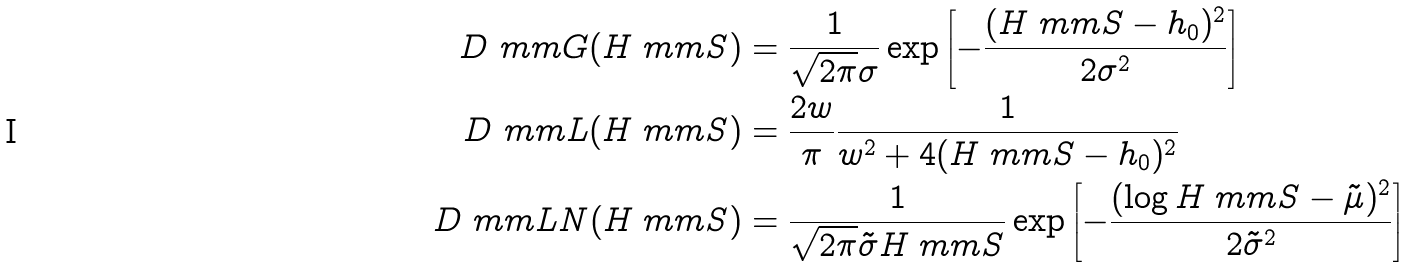Convert formula to latex. <formula><loc_0><loc_0><loc_500><loc_500>D _ { \ } m m { G } ( H _ { \ } m m { S } ) & = \frac { 1 } { \sqrt { 2 \pi } \sigma } \exp \left [ - \frac { ( H _ { \ } m m { S } - h _ { 0 } ) ^ { 2 } } { 2 \sigma ^ { 2 } } \right ] \\ D _ { \ } m m { L } ( H _ { \ } m m { S } ) & = \frac { 2 w } { \pi } \frac { 1 } { w ^ { 2 } + 4 ( H _ { \ } m m { S } - h _ { 0 } ) ^ { 2 } } \\ D _ { \ } m m { L N } ( H _ { \ } m m { S } ) & = \frac { 1 } { \sqrt { 2 \pi } \tilde { \sigma } H _ { \ } m m { S } } \exp \left [ - \frac { ( \log H _ { \ } m m { S } - \tilde { \mu } ) ^ { 2 } } { 2 \tilde { \sigma } ^ { 2 } } \right ]</formula> 